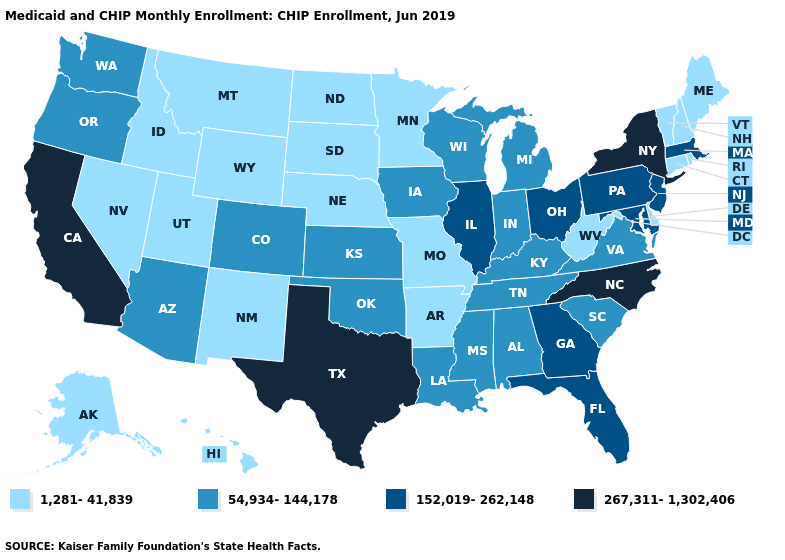What is the highest value in the USA?
Keep it brief. 267,311-1,302,406. Name the states that have a value in the range 54,934-144,178?
Keep it brief. Alabama, Arizona, Colorado, Indiana, Iowa, Kansas, Kentucky, Louisiana, Michigan, Mississippi, Oklahoma, Oregon, South Carolina, Tennessee, Virginia, Washington, Wisconsin. Name the states that have a value in the range 54,934-144,178?
Quick response, please. Alabama, Arizona, Colorado, Indiana, Iowa, Kansas, Kentucky, Louisiana, Michigan, Mississippi, Oklahoma, Oregon, South Carolina, Tennessee, Virginia, Washington, Wisconsin. What is the lowest value in states that border Mississippi?
Short answer required. 1,281-41,839. Name the states that have a value in the range 54,934-144,178?
Concise answer only. Alabama, Arizona, Colorado, Indiana, Iowa, Kansas, Kentucky, Louisiana, Michigan, Mississippi, Oklahoma, Oregon, South Carolina, Tennessee, Virginia, Washington, Wisconsin. Name the states that have a value in the range 152,019-262,148?
Answer briefly. Florida, Georgia, Illinois, Maryland, Massachusetts, New Jersey, Ohio, Pennsylvania. What is the value of Hawaii?
Concise answer only. 1,281-41,839. What is the value of Alabama?
Give a very brief answer. 54,934-144,178. Name the states that have a value in the range 267,311-1,302,406?
Answer briefly. California, New York, North Carolina, Texas. What is the value of Rhode Island?
Write a very short answer. 1,281-41,839. What is the highest value in the USA?
Short answer required. 267,311-1,302,406. What is the value of Massachusetts?
Keep it brief. 152,019-262,148. Name the states that have a value in the range 1,281-41,839?
Concise answer only. Alaska, Arkansas, Connecticut, Delaware, Hawaii, Idaho, Maine, Minnesota, Missouri, Montana, Nebraska, Nevada, New Hampshire, New Mexico, North Dakota, Rhode Island, South Dakota, Utah, Vermont, West Virginia, Wyoming. Does Illinois have the highest value in the MidWest?
Answer briefly. Yes. Among the states that border Vermont , does New Hampshire have the lowest value?
Quick response, please. Yes. 